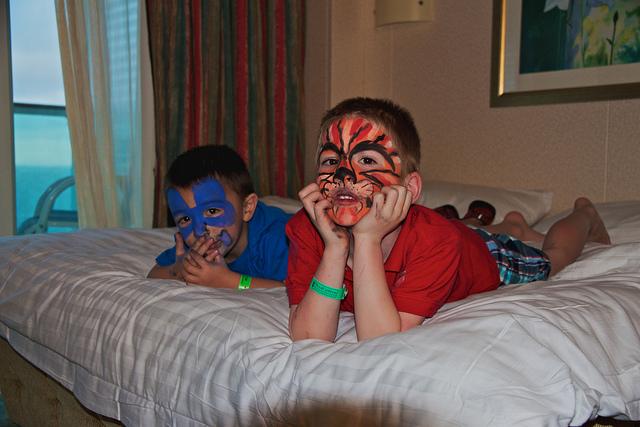How many people laying on the bed?
Be succinct. 2. What color is the bedspread?
Give a very brief answer. White. How many curtains are there?
Short answer required. 2. Where have the boys been?
Give a very brief answer. Face painting. What are these kids doing?
Write a very short answer. Laying down. What is on the boys faces?
Quick response, please. Paint. How many white pillows are there?
Answer briefly. 1. What is the blanket called that is on the bed?
Be succinct. Comforter. What is the boy holding?
Write a very short answer. His face. 